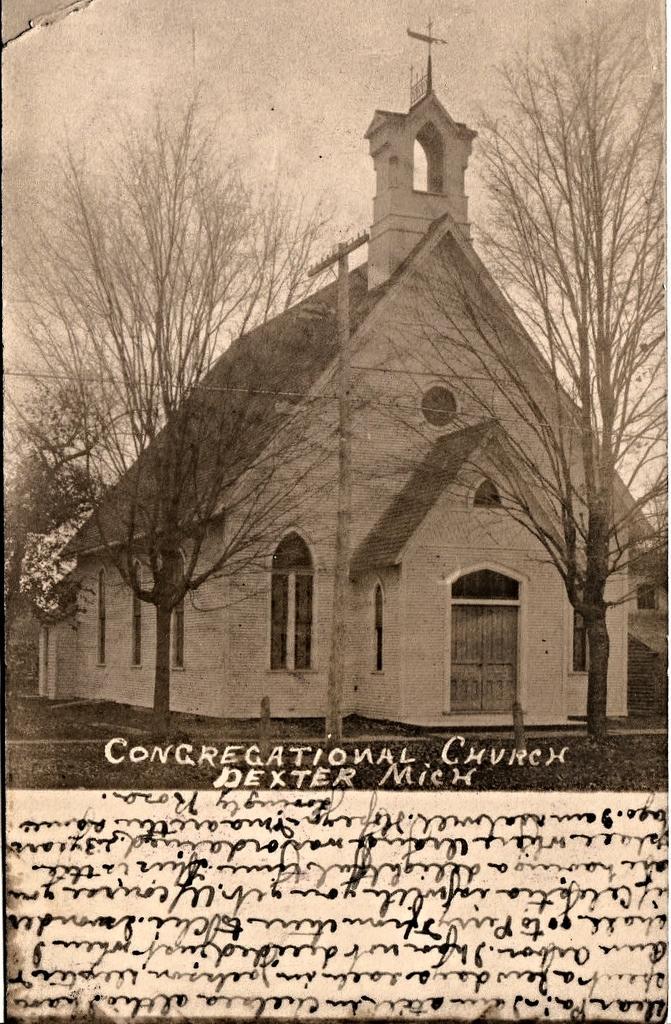What can be found in the foreground of the poster? There is text in the foreground of the poster. What type of natural environment is depicted in the image? There are trees and grass in the image, suggesting a natural environment. What type of structure is present in the image? There is a building in the image. What are the poles used for in the image? The purpose of the poles is not specified, but they could be used for various purposes such as signage or lighting. What is visible in the background of the image? The sky is visible in the image. What type of bubble can be seen floating in the image? There is no bubble present in the image. What type of street is visible in the image? There is no street visible in the image; it features a natural environment with trees, grass, and a building. 